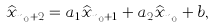Convert formula to latex. <formula><loc_0><loc_0><loc_500><loc_500>\widehat { x } _ { n _ { 0 } + 2 } = a _ { 1 } \widehat { x } _ { n _ { 0 } + 1 } + a _ { 2 } \widehat { x } _ { n _ { 0 } } + b ,</formula> 